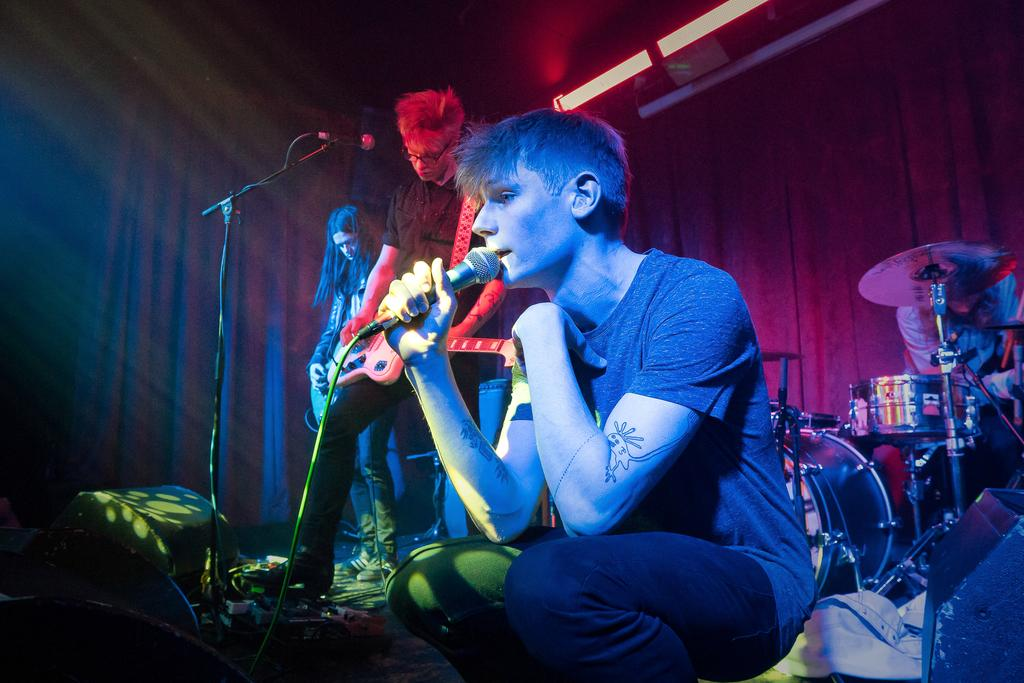How many people are in the image? There are four persons in the image. What are the four persons doing in the image? The four persons are performing a live band. Can you describe any background elements in the image? Yes, there is a curtain in the image. What color are the lights visible at the top of the image? The lights visible at the top of the image are red. What type of soap is being used by the band members in the image? There is no soap present in the image, as it features a live band performing. Is there a train visible in the image? No, there is no train present in the image. 